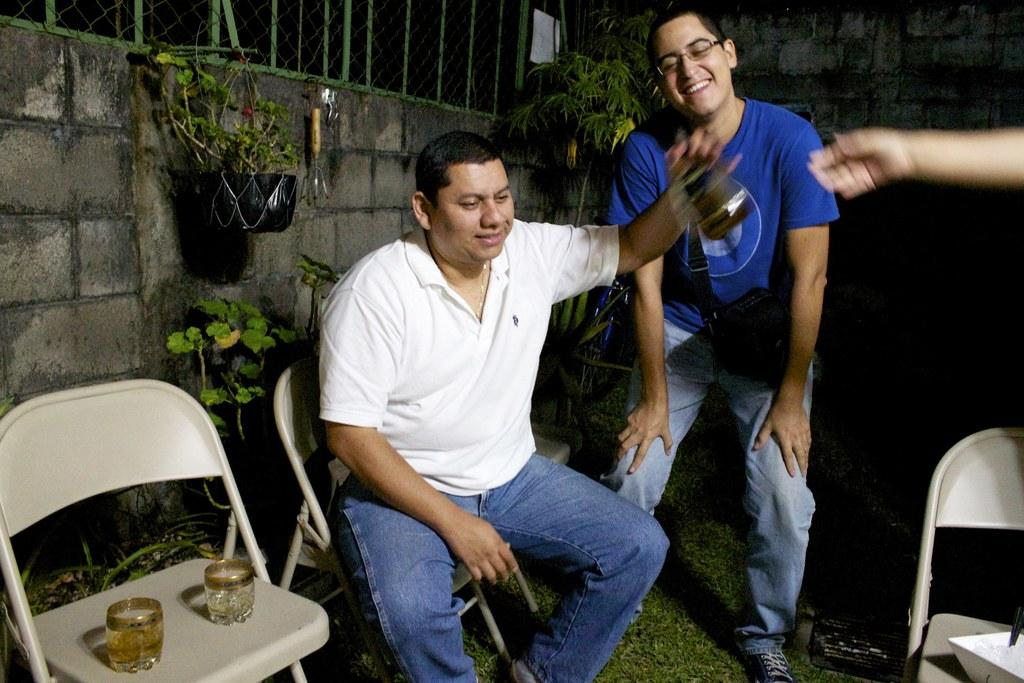What is the sitting man doing in the image? There is a man sitting in a chair in the image. What is the standing man doing in the image? There is another man standing and smiling beside the sitting man. Can you describe the background of the image? There are chairs, glasses, plants, a net, a tree, iron grills, and grass in the background of the image. What type of tax is being discussed by the men in the image? There is no indication in the image that the men are discussing any taxes. 